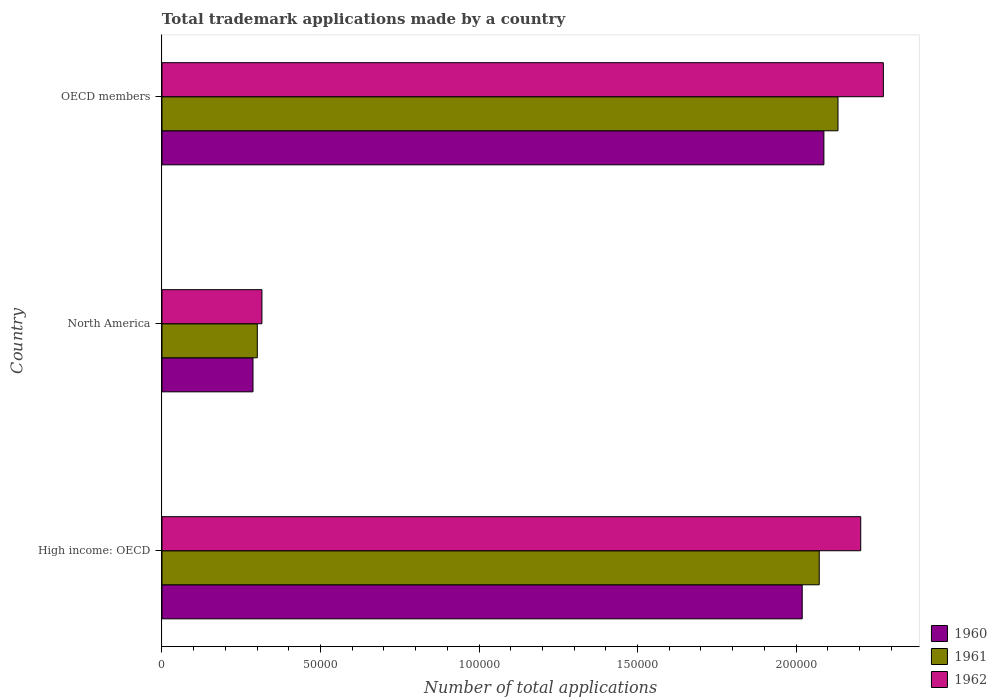Are the number of bars per tick equal to the number of legend labels?
Your response must be concise. Yes. Are the number of bars on each tick of the Y-axis equal?
Your answer should be compact. Yes. How many bars are there on the 3rd tick from the bottom?
Offer a terse response. 3. What is the label of the 3rd group of bars from the top?
Your response must be concise. High income: OECD. In how many cases, is the number of bars for a given country not equal to the number of legend labels?
Ensure brevity in your answer.  0. What is the number of applications made by in 1961 in High income: OECD?
Keep it short and to the point. 2.07e+05. Across all countries, what is the maximum number of applications made by in 1962?
Offer a terse response. 2.28e+05. Across all countries, what is the minimum number of applications made by in 1962?
Give a very brief answer. 3.15e+04. What is the total number of applications made by in 1961 in the graph?
Keep it short and to the point. 4.51e+05. What is the difference between the number of applications made by in 1961 in High income: OECD and that in North America?
Provide a succinct answer. 1.77e+05. What is the difference between the number of applications made by in 1962 in High income: OECD and the number of applications made by in 1960 in OECD members?
Provide a succinct answer. 1.16e+04. What is the average number of applications made by in 1962 per country?
Give a very brief answer. 1.60e+05. What is the difference between the number of applications made by in 1961 and number of applications made by in 1960 in North America?
Offer a terse response. 1355. In how many countries, is the number of applications made by in 1962 greater than 180000 ?
Give a very brief answer. 2. What is the ratio of the number of applications made by in 1960 in North America to that in OECD members?
Your response must be concise. 0.14. Is the difference between the number of applications made by in 1961 in High income: OECD and North America greater than the difference between the number of applications made by in 1960 in High income: OECD and North America?
Make the answer very short. Yes. What is the difference between the highest and the second highest number of applications made by in 1962?
Give a very brief answer. 7139. What is the difference between the highest and the lowest number of applications made by in 1960?
Your response must be concise. 1.80e+05. In how many countries, is the number of applications made by in 1962 greater than the average number of applications made by in 1962 taken over all countries?
Make the answer very short. 2. How many countries are there in the graph?
Offer a terse response. 3. Does the graph contain grids?
Provide a short and direct response. No. How are the legend labels stacked?
Offer a very short reply. Vertical. What is the title of the graph?
Keep it short and to the point. Total trademark applications made by a country. What is the label or title of the X-axis?
Your response must be concise. Number of total applications. What is the Number of total applications in 1960 in High income: OECD?
Provide a short and direct response. 2.02e+05. What is the Number of total applications in 1961 in High income: OECD?
Your answer should be compact. 2.07e+05. What is the Number of total applications of 1962 in High income: OECD?
Make the answer very short. 2.20e+05. What is the Number of total applications in 1960 in North America?
Provide a succinct answer. 2.87e+04. What is the Number of total applications of 1961 in North America?
Offer a very short reply. 3.01e+04. What is the Number of total applications in 1962 in North America?
Keep it short and to the point. 3.15e+04. What is the Number of total applications in 1960 in OECD members?
Make the answer very short. 2.09e+05. What is the Number of total applications of 1961 in OECD members?
Make the answer very short. 2.13e+05. What is the Number of total applications in 1962 in OECD members?
Provide a succinct answer. 2.28e+05. Across all countries, what is the maximum Number of total applications in 1960?
Keep it short and to the point. 2.09e+05. Across all countries, what is the maximum Number of total applications of 1961?
Make the answer very short. 2.13e+05. Across all countries, what is the maximum Number of total applications of 1962?
Your response must be concise. 2.28e+05. Across all countries, what is the minimum Number of total applications in 1960?
Provide a short and direct response. 2.87e+04. Across all countries, what is the minimum Number of total applications in 1961?
Keep it short and to the point. 3.01e+04. Across all countries, what is the minimum Number of total applications in 1962?
Give a very brief answer. 3.15e+04. What is the total Number of total applications of 1960 in the graph?
Offer a very short reply. 4.39e+05. What is the total Number of total applications of 1961 in the graph?
Your answer should be compact. 4.51e+05. What is the total Number of total applications in 1962 in the graph?
Keep it short and to the point. 4.79e+05. What is the difference between the Number of total applications of 1960 in High income: OECD and that in North America?
Your answer should be very brief. 1.73e+05. What is the difference between the Number of total applications of 1961 in High income: OECD and that in North America?
Provide a short and direct response. 1.77e+05. What is the difference between the Number of total applications in 1962 in High income: OECD and that in North America?
Ensure brevity in your answer.  1.89e+05. What is the difference between the Number of total applications in 1960 in High income: OECD and that in OECD members?
Give a very brief answer. -6833. What is the difference between the Number of total applications of 1961 in High income: OECD and that in OECD members?
Offer a terse response. -5917. What is the difference between the Number of total applications of 1962 in High income: OECD and that in OECD members?
Your answer should be very brief. -7139. What is the difference between the Number of total applications of 1960 in North America and that in OECD members?
Offer a very short reply. -1.80e+05. What is the difference between the Number of total applications in 1961 in North America and that in OECD members?
Offer a terse response. -1.83e+05. What is the difference between the Number of total applications in 1962 in North America and that in OECD members?
Keep it short and to the point. -1.96e+05. What is the difference between the Number of total applications in 1960 in High income: OECD and the Number of total applications in 1961 in North America?
Your answer should be compact. 1.72e+05. What is the difference between the Number of total applications in 1960 in High income: OECD and the Number of total applications in 1962 in North America?
Your response must be concise. 1.70e+05. What is the difference between the Number of total applications in 1961 in High income: OECD and the Number of total applications in 1962 in North America?
Offer a terse response. 1.76e+05. What is the difference between the Number of total applications in 1960 in High income: OECD and the Number of total applications in 1961 in OECD members?
Ensure brevity in your answer.  -1.13e+04. What is the difference between the Number of total applications of 1960 in High income: OECD and the Number of total applications of 1962 in OECD members?
Offer a terse response. -2.56e+04. What is the difference between the Number of total applications of 1961 in High income: OECD and the Number of total applications of 1962 in OECD members?
Give a very brief answer. -2.02e+04. What is the difference between the Number of total applications of 1960 in North America and the Number of total applications of 1961 in OECD members?
Offer a terse response. -1.85e+05. What is the difference between the Number of total applications of 1960 in North America and the Number of total applications of 1962 in OECD members?
Offer a very short reply. -1.99e+05. What is the difference between the Number of total applications in 1961 in North America and the Number of total applications in 1962 in OECD members?
Your response must be concise. -1.97e+05. What is the average Number of total applications in 1960 per country?
Provide a succinct answer. 1.46e+05. What is the average Number of total applications in 1961 per country?
Offer a terse response. 1.50e+05. What is the average Number of total applications in 1962 per country?
Give a very brief answer. 1.60e+05. What is the difference between the Number of total applications of 1960 and Number of total applications of 1961 in High income: OECD?
Make the answer very short. -5368. What is the difference between the Number of total applications in 1960 and Number of total applications in 1962 in High income: OECD?
Ensure brevity in your answer.  -1.85e+04. What is the difference between the Number of total applications in 1961 and Number of total applications in 1962 in High income: OECD?
Your answer should be compact. -1.31e+04. What is the difference between the Number of total applications in 1960 and Number of total applications in 1961 in North America?
Offer a very short reply. -1355. What is the difference between the Number of total applications in 1960 and Number of total applications in 1962 in North America?
Your answer should be very brief. -2817. What is the difference between the Number of total applications of 1961 and Number of total applications of 1962 in North America?
Offer a terse response. -1462. What is the difference between the Number of total applications in 1960 and Number of total applications in 1961 in OECD members?
Offer a terse response. -4452. What is the difference between the Number of total applications in 1960 and Number of total applications in 1962 in OECD members?
Your answer should be compact. -1.88e+04. What is the difference between the Number of total applications in 1961 and Number of total applications in 1962 in OECD members?
Ensure brevity in your answer.  -1.43e+04. What is the ratio of the Number of total applications in 1960 in High income: OECD to that in North America?
Ensure brevity in your answer.  7.03. What is the ratio of the Number of total applications of 1961 in High income: OECD to that in North America?
Your answer should be very brief. 6.9. What is the ratio of the Number of total applications in 1962 in High income: OECD to that in North America?
Ensure brevity in your answer.  6.99. What is the ratio of the Number of total applications of 1960 in High income: OECD to that in OECD members?
Offer a very short reply. 0.97. What is the ratio of the Number of total applications of 1961 in High income: OECD to that in OECD members?
Your answer should be compact. 0.97. What is the ratio of the Number of total applications of 1962 in High income: OECD to that in OECD members?
Offer a terse response. 0.97. What is the ratio of the Number of total applications of 1960 in North America to that in OECD members?
Keep it short and to the point. 0.14. What is the ratio of the Number of total applications of 1961 in North America to that in OECD members?
Provide a succinct answer. 0.14. What is the ratio of the Number of total applications of 1962 in North America to that in OECD members?
Provide a succinct answer. 0.14. What is the difference between the highest and the second highest Number of total applications in 1960?
Provide a short and direct response. 6833. What is the difference between the highest and the second highest Number of total applications in 1961?
Your answer should be compact. 5917. What is the difference between the highest and the second highest Number of total applications in 1962?
Ensure brevity in your answer.  7139. What is the difference between the highest and the lowest Number of total applications of 1960?
Your response must be concise. 1.80e+05. What is the difference between the highest and the lowest Number of total applications in 1961?
Keep it short and to the point. 1.83e+05. What is the difference between the highest and the lowest Number of total applications in 1962?
Your response must be concise. 1.96e+05. 